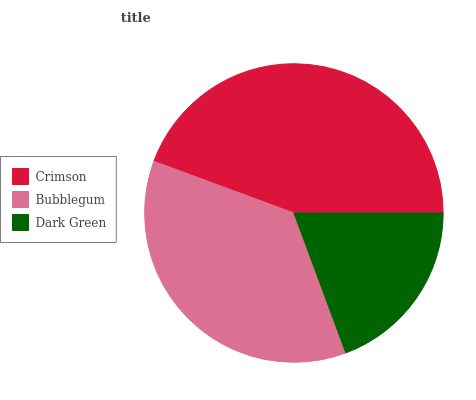Is Dark Green the minimum?
Answer yes or no. Yes. Is Crimson the maximum?
Answer yes or no. Yes. Is Bubblegum the minimum?
Answer yes or no. No. Is Bubblegum the maximum?
Answer yes or no. No. Is Crimson greater than Bubblegum?
Answer yes or no. Yes. Is Bubblegum less than Crimson?
Answer yes or no. Yes. Is Bubblegum greater than Crimson?
Answer yes or no. No. Is Crimson less than Bubblegum?
Answer yes or no. No. Is Bubblegum the high median?
Answer yes or no. Yes. Is Bubblegum the low median?
Answer yes or no. Yes. Is Dark Green the high median?
Answer yes or no. No. Is Crimson the low median?
Answer yes or no. No. 